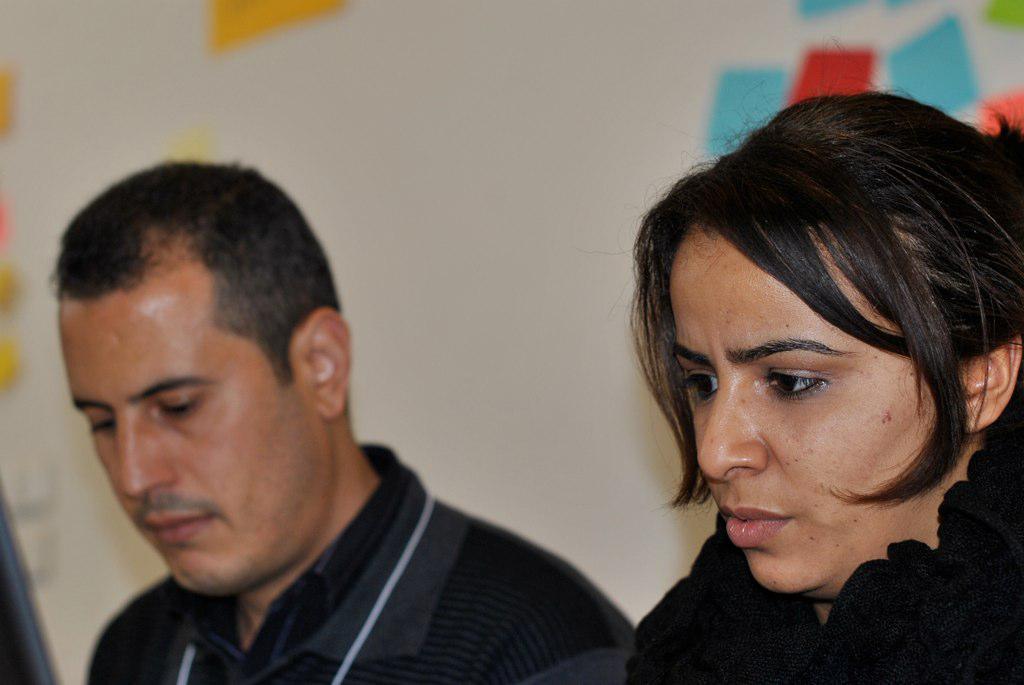In one or two sentences, can you explain what this image depicts? In this image we can see a man and a lady. In the background there is a wall. 